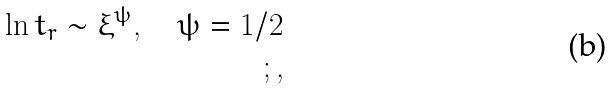Convert formula to latex. <formula><loc_0><loc_0><loc_500><loc_500>\ln t _ { r } \sim \xi ^ { \psi } , \quad \psi = 1 / 2 \\ ; ,</formula> 